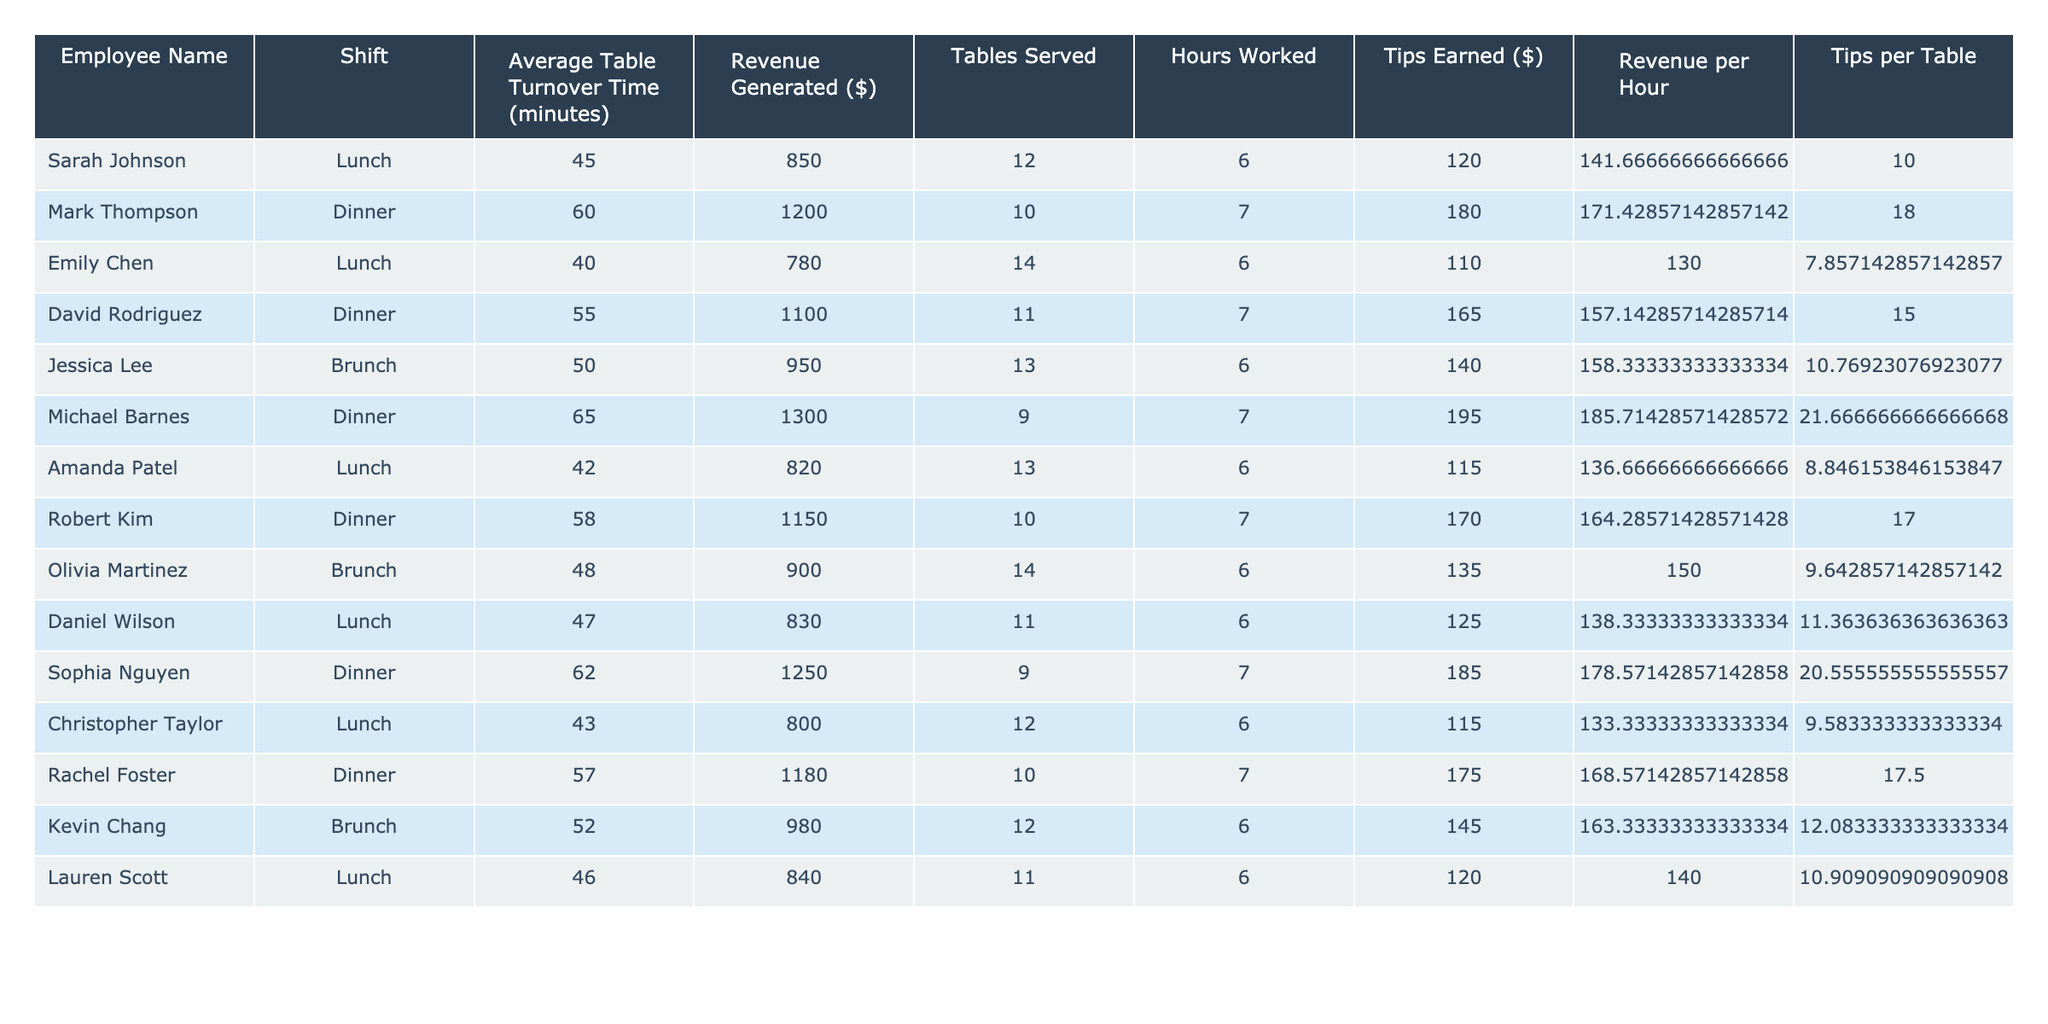What is the revenue generated by Sarah Johnson during her lunch shift? From the table, Sarah Johnson's entry shows that she generated $850 during her lunch shift.
Answer: 850 Which employee had the highest average table turnover time? Michael Barnes had the highest average table turnover time at 65 minutes, as indicated in the table.
Answer: 65 What is the total revenue generated by all employees during brunch shifts? The table shows two employees during brunch: Jessica Lee generated $950 and Olivia Martinez generated $900. Adding these amounts gives $950 + $900 = $1850.
Answer: 1850 Who earned the most in tips among the employees? By comparing the "Tips Earned" column, Michael Barnes earned $195 in tips, which is the highest in the table.
Answer: 195 What is the average revenue generated per shift by all employees? To find the average, sum all the revenues ($850 + $1200 + $780 + ... + $840 = $11,030) and divide by the number of shifts (12). Thus, the average revenue generated is $11,030 / 12 = $919.17.
Answer: 919.17 Did any employee have a table turnover time of less than 45 minutes? Checking the "Average Table Turnover Time" column, Emily Chen had a turnover time of 40 minutes, which is less than 45.
Answer: Yes What is the difference in revenue generated between the employee with the highest and lowest revenue? The highest revenue generated is by Michael Barnes at $1300, and the lowest is Emily Chen at $780. The difference is $1300 - $780 = $520.
Answer: 520 Which shift has the lowest average table turnover time? By reviewing the averages for each shift, the Lunch shift has an average of 44.5 minutes while other shifts have higher averages (Brunch: 50 minutes, Dinner: 58.5 minutes).
Answer: Lunch How much revenue did each employee generate per hour? To find this, divide the revenue generated by hours worked for each employee. For example, Sarah Johnson made $850 in 6 hours, which equals $141.67 per hour.
Answer: Varies by employee Which employee served the most tables during their shift? From the table, Emily Chen served the most tables at 14 during her lunch shift.
Answer: Emily Chen What is the total tips earned by all employees on dinner shifts? Looking at the "Tips Earned" column for dinner shifts, the amounts are $180, $165, $195, $170, and $175. Summing these gives $180 + $165 + $195 + $170 + $175 = $985.
Answer: 985 Is there an employee who had both the highest revenue and the highest tips? By reviewing the table, yes, Michael Barnes not only generated the highest revenue ($1300) but also had the highest tips earned ($195).
Answer: Yes 